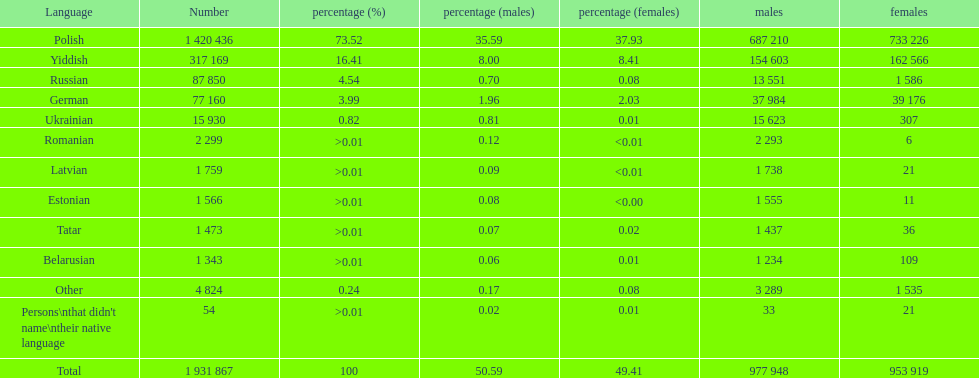Which language had the most number of people speaking it. Polish. 